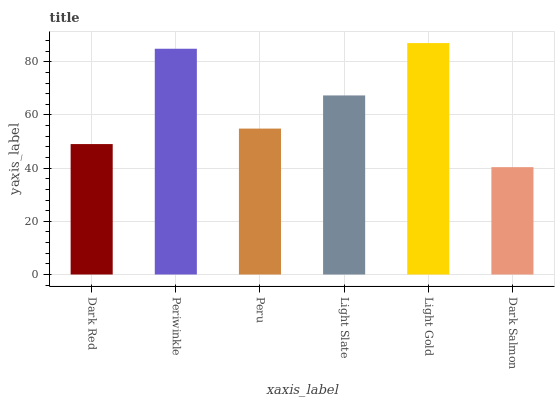Is Dark Salmon the minimum?
Answer yes or no. Yes. Is Light Gold the maximum?
Answer yes or no. Yes. Is Periwinkle the minimum?
Answer yes or no. No. Is Periwinkle the maximum?
Answer yes or no. No. Is Periwinkle greater than Dark Red?
Answer yes or no. Yes. Is Dark Red less than Periwinkle?
Answer yes or no. Yes. Is Dark Red greater than Periwinkle?
Answer yes or no. No. Is Periwinkle less than Dark Red?
Answer yes or no. No. Is Light Slate the high median?
Answer yes or no. Yes. Is Peru the low median?
Answer yes or no. Yes. Is Dark Red the high median?
Answer yes or no. No. Is Light Slate the low median?
Answer yes or no. No. 